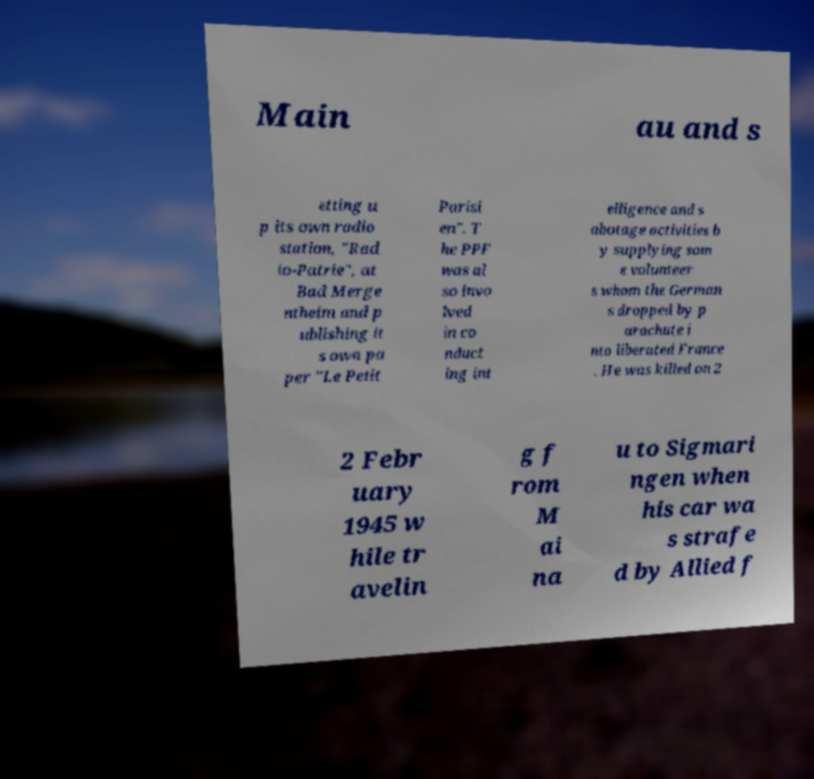Please read and relay the text visible in this image. What does it say? Main au and s etting u p its own radio station, "Rad io-Patrie", at Bad Merge ntheim and p ublishing it s own pa per "Le Petit Parisi en". T he PPF was al so invo lved in co nduct ing int elligence and s abotage activities b y supplying som e volunteer s whom the German s dropped by p arachute i nto liberated France . He was killed on 2 2 Febr uary 1945 w hile tr avelin g f rom M ai na u to Sigmari ngen when his car wa s strafe d by Allied f 